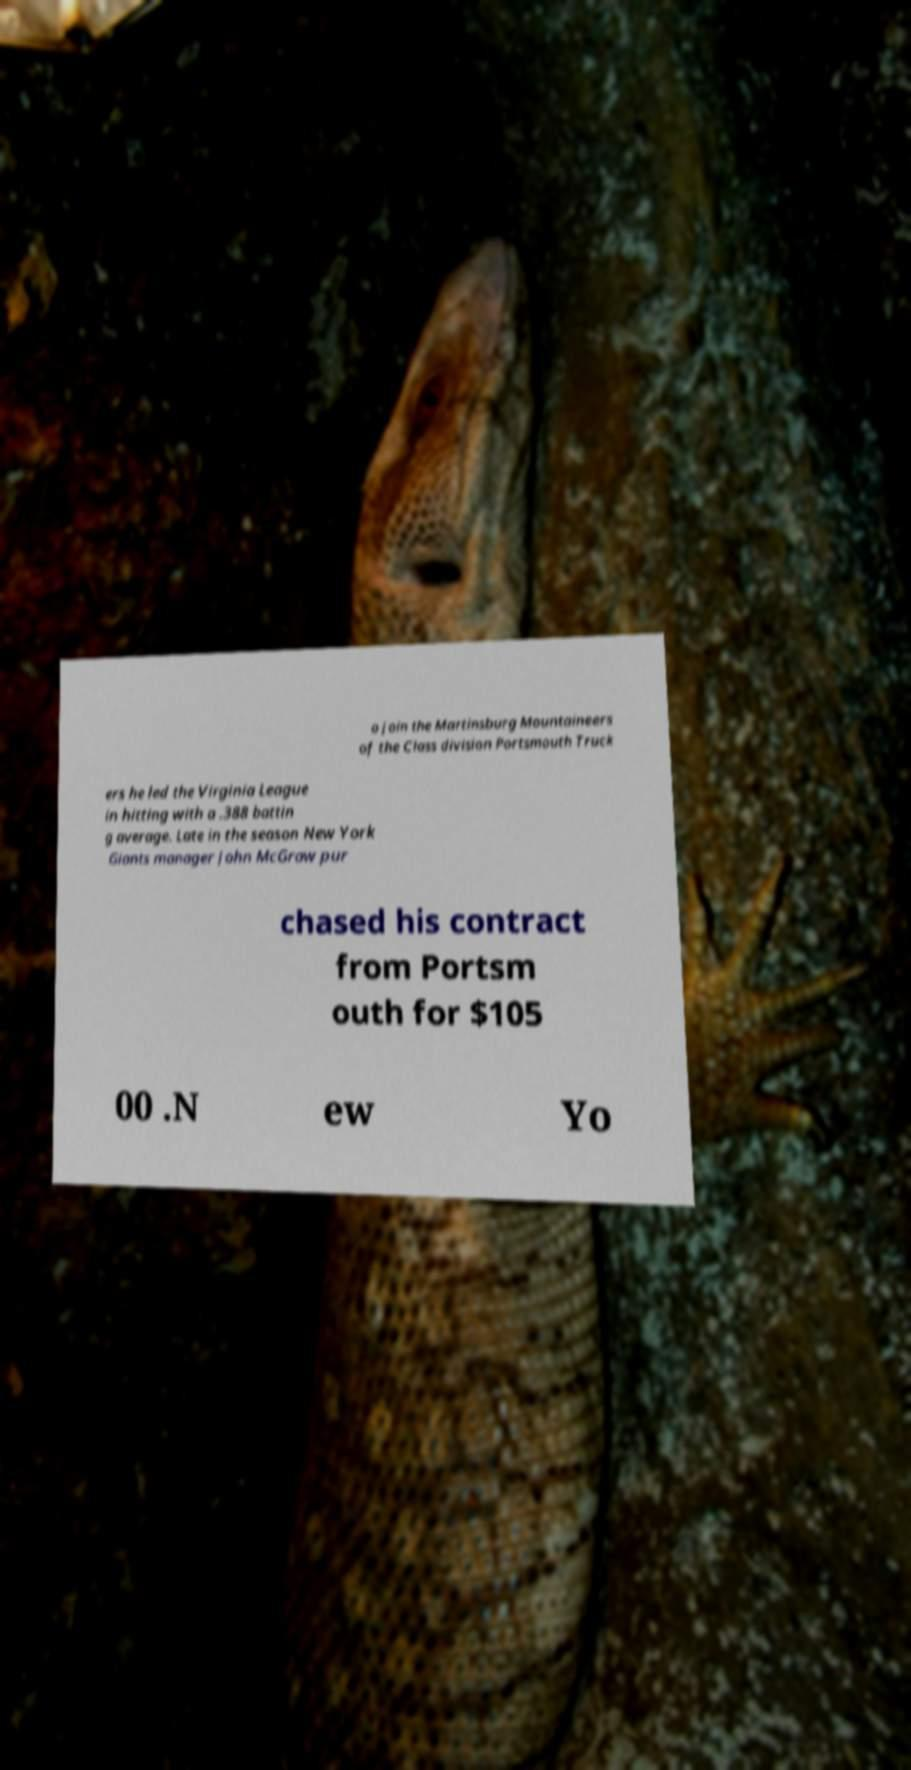Can you read and provide the text displayed in the image?This photo seems to have some interesting text. Can you extract and type it out for me? o join the Martinsburg Mountaineers of the Class division Portsmouth Truck ers he led the Virginia League in hitting with a .388 battin g average. Late in the season New York Giants manager John McGraw pur chased his contract from Portsm outh for $105 00 .N ew Yo 